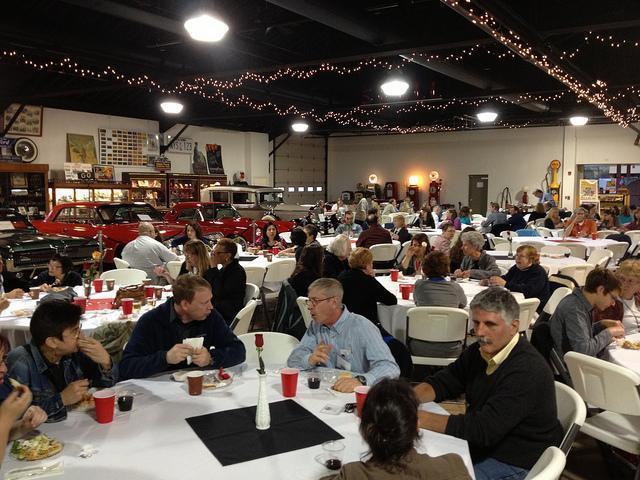How many people can you see?
Give a very brief answer. 10. How many chairs are in the photo?
Give a very brief answer. 3. How many dining tables are visible?
Give a very brief answer. 2. How many cars are in the photo?
Give a very brief answer. 4. 